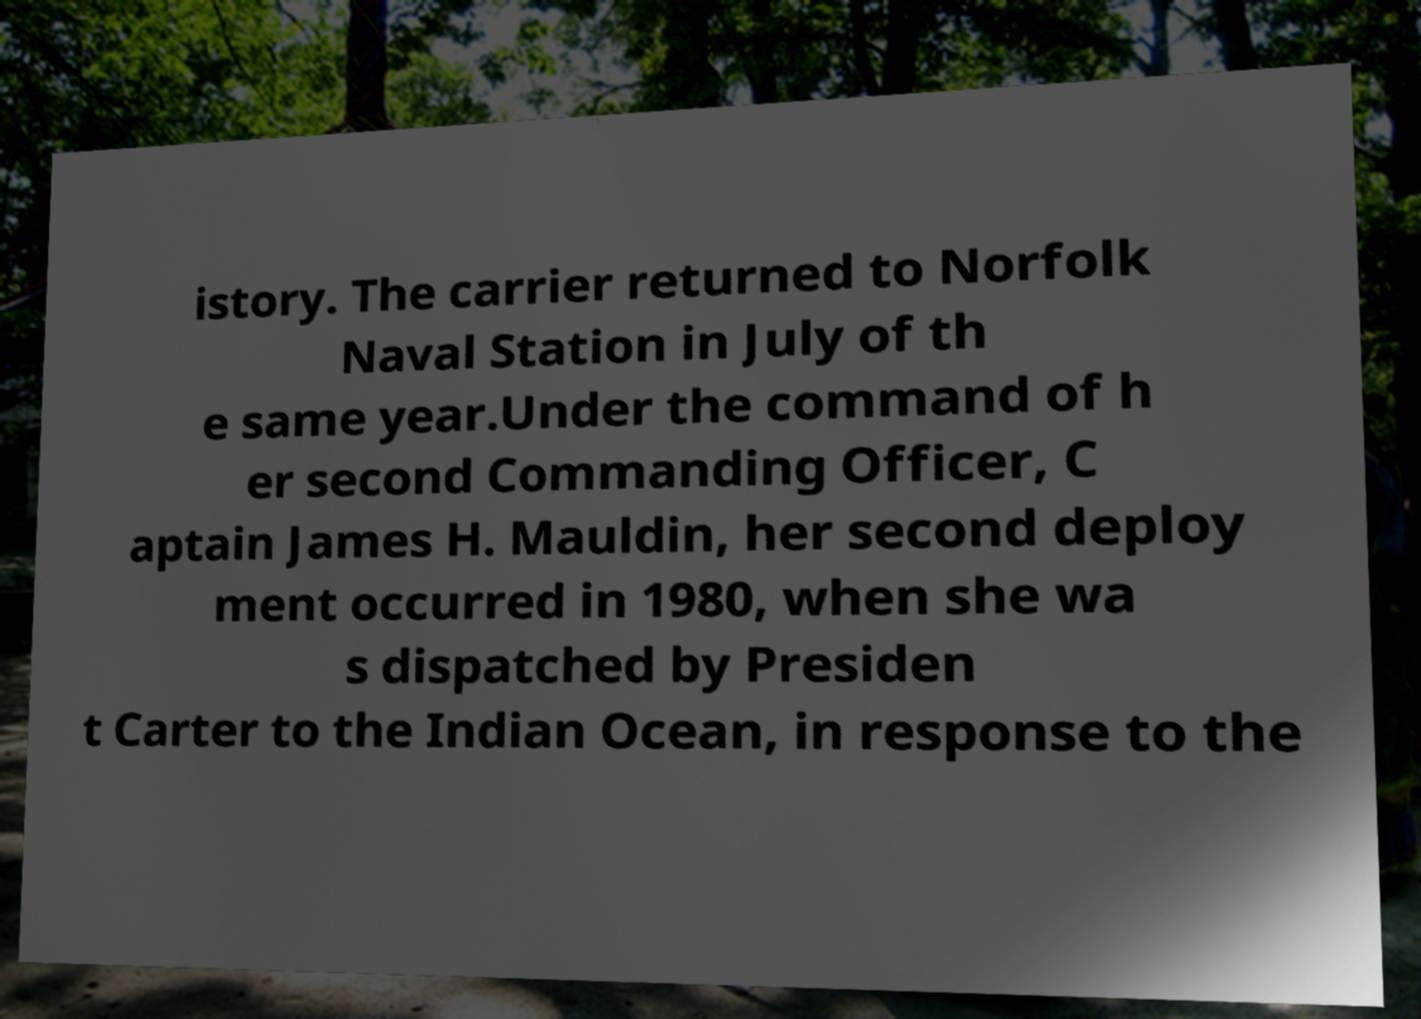Can you accurately transcribe the text from the provided image for me? istory. The carrier returned to Norfolk Naval Station in July of th e same year.Under the command of h er second Commanding Officer, C aptain James H. Mauldin, her second deploy ment occurred in 1980, when she wa s dispatched by Presiden t Carter to the Indian Ocean, in response to the 